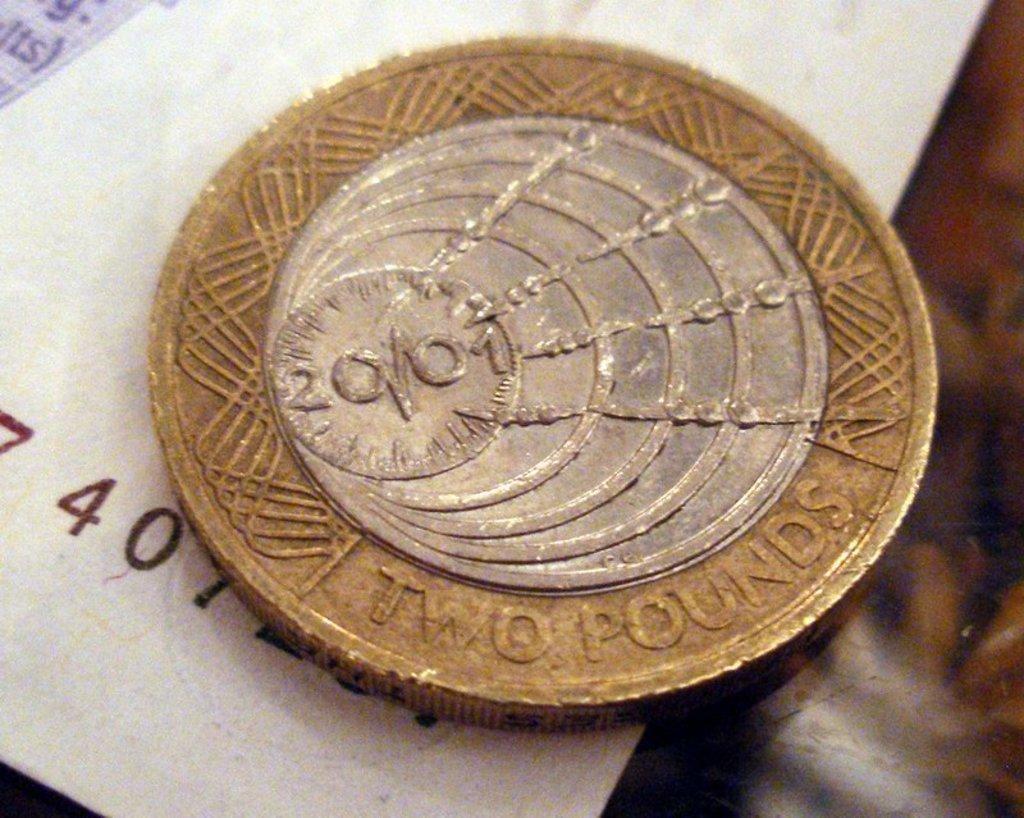Describe this image in one or two sentences. We can see coin and white object on the surface. 